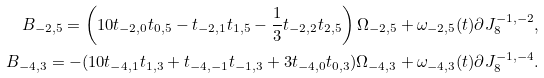<formula> <loc_0><loc_0><loc_500><loc_500>B _ { - 2 , 5 } = \left ( 1 0 t _ { - 2 , 0 } t _ { 0 , 5 } - t _ { - 2 , 1 } t _ { 1 , 5 } - \frac { 1 } { 3 } t _ { - 2 , 2 } t _ { 2 , 5 } \right ) \Omega _ { - 2 , 5 } + \omega _ { - 2 , 5 } ( t ) \partial J _ { 8 } ^ { - 1 , - 2 } , \\ B _ { - 4 , 3 } = - ( 1 0 t _ { - 4 , 1 } t _ { 1 , 3 } + t _ { - 4 , - 1 } t _ { - 1 , 3 } + 3 t _ { - 4 , 0 } t _ { 0 , 3 } ) \Omega _ { - 4 , 3 } + \omega _ { - 4 , 3 } ( t ) \partial J _ { 8 } ^ { - 1 , - 4 } .</formula> 